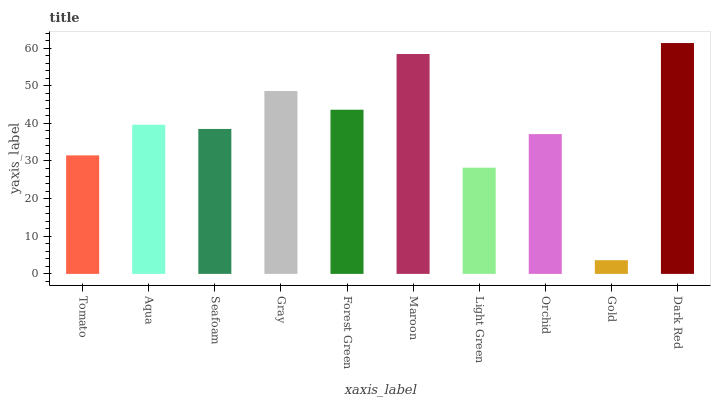Is Gold the minimum?
Answer yes or no. Yes. Is Dark Red the maximum?
Answer yes or no. Yes. Is Aqua the minimum?
Answer yes or no. No. Is Aqua the maximum?
Answer yes or no. No. Is Aqua greater than Tomato?
Answer yes or no. Yes. Is Tomato less than Aqua?
Answer yes or no. Yes. Is Tomato greater than Aqua?
Answer yes or no. No. Is Aqua less than Tomato?
Answer yes or no. No. Is Aqua the high median?
Answer yes or no. Yes. Is Seafoam the low median?
Answer yes or no. Yes. Is Gray the high median?
Answer yes or no. No. Is Maroon the low median?
Answer yes or no. No. 